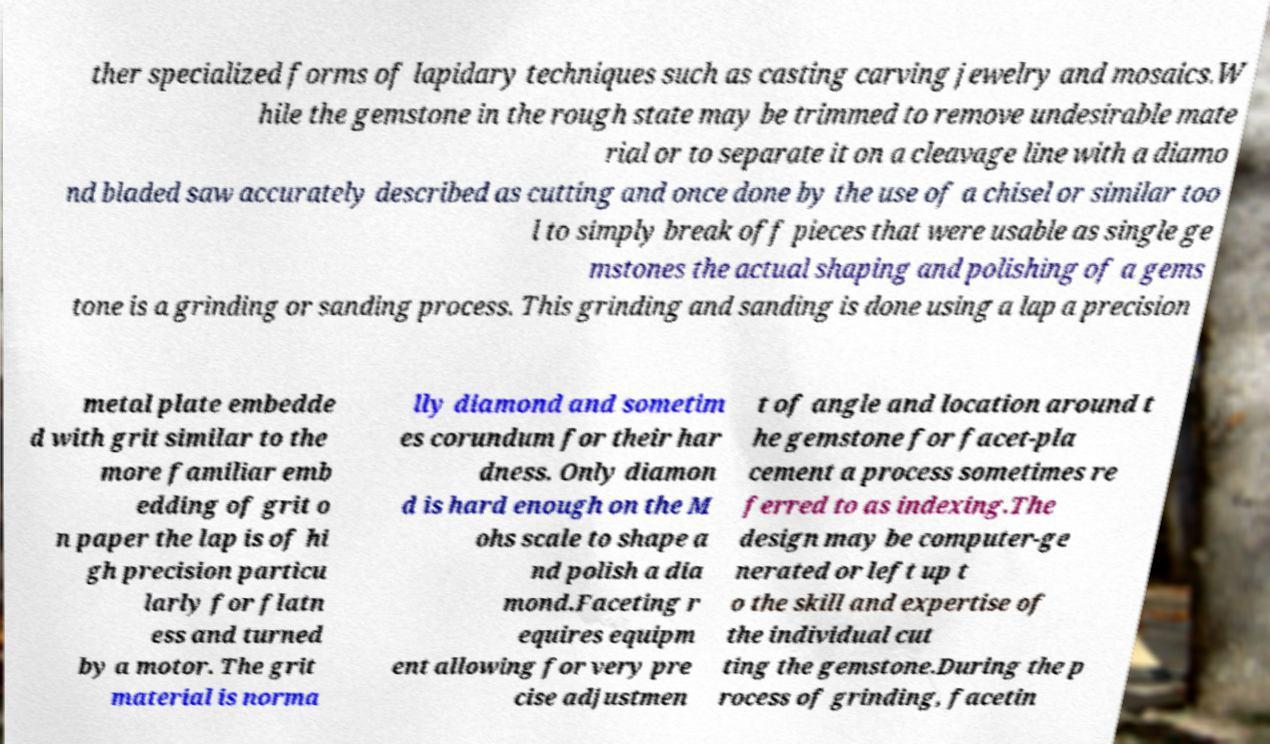Please identify and transcribe the text found in this image. ther specialized forms of lapidary techniques such as casting carving jewelry and mosaics.W hile the gemstone in the rough state may be trimmed to remove undesirable mate rial or to separate it on a cleavage line with a diamo nd bladed saw accurately described as cutting and once done by the use of a chisel or similar too l to simply break off pieces that were usable as single ge mstones the actual shaping and polishing of a gems tone is a grinding or sanding process. This grinding and sanding is done using a lap a precision metal plate embedde d with grit similar to the more familiar emb edding of grit o n paper the lap is of hi gh precision particu larly for flatn ess and turned by a motor. The grit material is norma lly diamond and sometim es corundum for their har dness. Only diamon d is hard enough on the M ohs scale to shape a nd polish a dia mond.Faceting r equires equipm ent allowing for very pre cise adjustmen t of angle and location around t he gemstone for facet-pla cement a process sometimes re ferred to as indexing.The design may be computer-ge nerated or left up t o the skill and expertise of the individual cut ting the gemstone.During the p rocess of grinding, facetin 